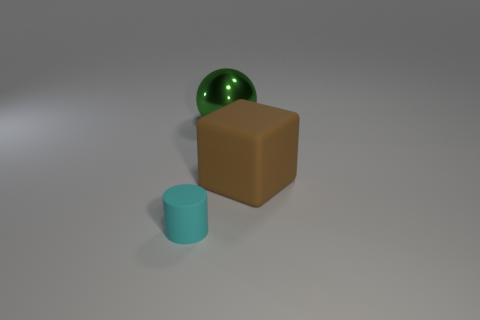Subtract all balls. How many objects are left? 2 Add 3 green rubber cubes. How many objects exist? 6 Subtract all green matte objects. Subtract all large green things. How many objects are left? 2 Add 1 brown cubes. How many brown cubes are left? 2 Add 1 tiny green cylinders. How many tiny green cylinders exist? 1 Subtract 0 brown cylinders. How many objects are left? 3 Subtract 1 cubes. How many cubes are left? 0 Subtract all red cylinders. Subtract all red blocks. How many cylinders are left? 1 Subtract all green cylinders. How many red spheres are left? 0 